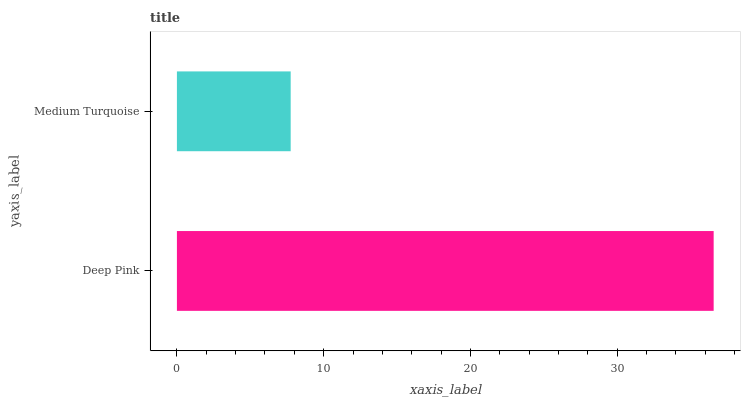Is Medium Turquoise the minimum?
Answer yes or no. Yes. Is Deep Pink the maximum?
Answer yes or no. Yes. Is Medium Turquoise the maximum?
Answer yes or no. No. Is Deep Pink greater than Medium Turquoise?
Answer yes or no. Yes. Is Medium Turquoise less than Deep Pink?
Answer yes or no. Yes. Is Medium Turquoise greater than Deep Pink?
Answer yes or no. No. Is Deep Pink less than Medium Turquoise?
Answer yes or no. No. Is Deep Pink the high median?
Answer yes or no. Yes. Is Medium Turquoise the low median?
Answer yes or no. Yes. Is Medium Turquoise the high median?
Answer yes or no. No. Is Deep Pink the low median?
Answer yes or no. No. 